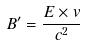Convert formula to latex. <formula><loc_0><loc_0><loc_500><loc_500>B ^ { \prime } = \frac { E \times v } { c ^ { 2 } }</formula> 